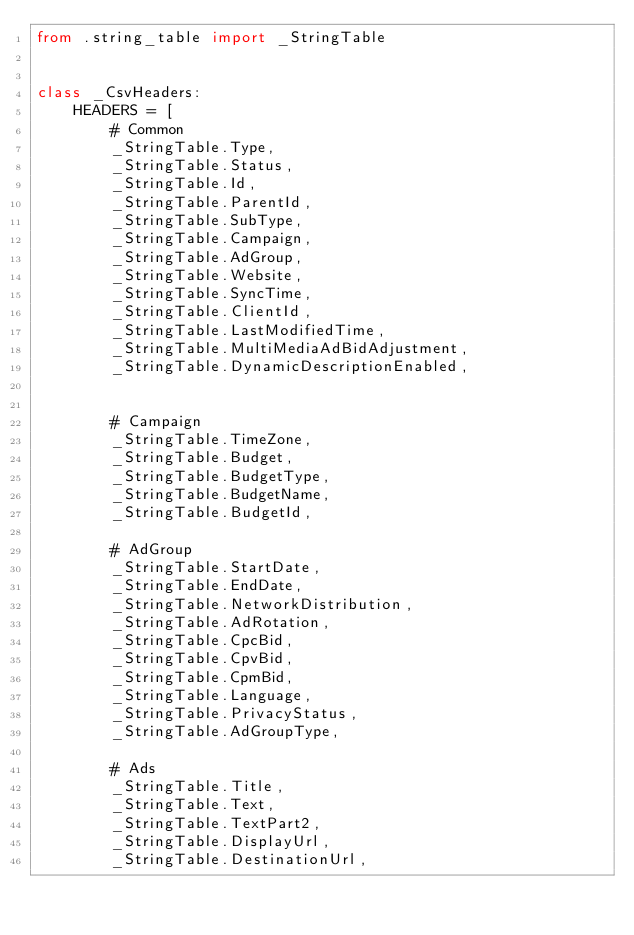<code> <loc_0><loc_0><loc_500><loc_500><_Python_>from .string_table import _StringTable


class _CsvHeaders:
    HEADERS = [
        # Common
        _StringTable.Type,
        _StringTable.Status,
        _StringTable.Id,
        _StringTable.ParentId,
        _StringTable.SubType,
        _StringTable.Campaign,
        _StringTable.AdGroup,
        _StringTable.Website,
        _StringTable.SyncTime,
        _StringTable.ClientId,
        _StringTable.LastModifiedTime,
        _StringTable.MultiMediaAdBidAdjustment,
        _StringTable.DynamicDescriptionEnabled,


        # Campaign
        _StringTable.TimeZone,
        _StringTable.Budget,
        _StringTable.BudgetType,
        _StringTable.BudgetName,
        _StringTable.BudgetId,

        # AdGroup
        _StringTable.StartDate,
        _StringTable.EndDate,
        _StringTable.NetworkDistribution,
        _StringTable.AdRotation,
        _StringTable.CpcBid,
        _StringTable.CpvBid,
        _StringTable.CpmBid,
        _StringTable.Language,
        _StringTable.PrivacyStatus,
        _StringTable.AdGroupType,

        # Ads
        _StringTable.Title,
        _StringTable.Text,
        _StringTable.TextPart2,
        _StringTable.DisplayUrl,
        _StringTable.DestinationUrl,</code> 